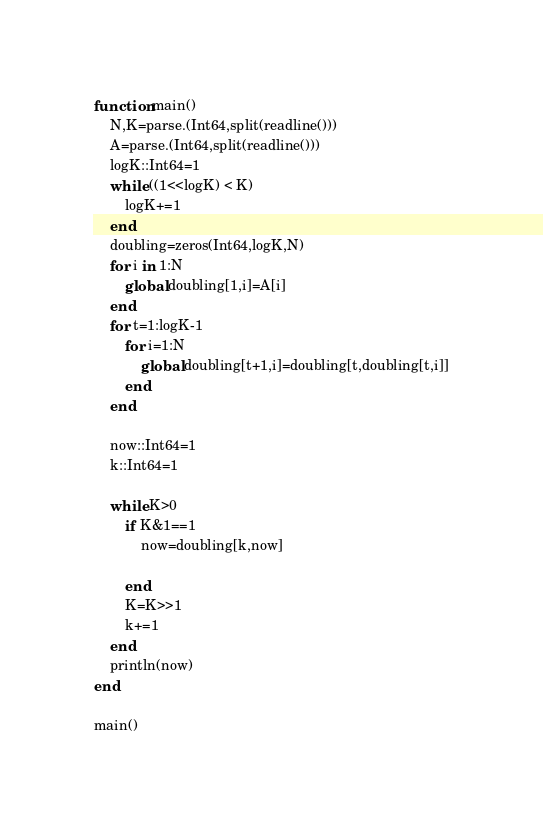Convert code to text. <code><loc_0><loc_0><loc_500><loc_500><_Julia_>function main()
    N,K=parse.(Int64,split(readline()))
    A=parse.(Int64,split(readline()))
    logK::Int64=1
    while ((1<<logK) < K)
        logK+=1
    end
    doubling=zeros(Int64,logK,N)
    for i in 1:N
        global doubling[1,i]=A[i]
    end
    for t=1:logK-1
        for i=1:N
            global doubling[t+1,i]=doubling[t,doubling[t,i]]
        end
    end
    
    now::Int64=1
    k::Int64=1
    
    while K>0
        if K&1==1
            now=doubling[k,now]
            
        end
        K=K>>1
        k+=1
    end
    println(now)
end

main()
</code> 